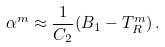<formula> <loc_0><loc_0><loc_500><loc_500>\alpha ^ { m } \approx \frac { 1 } { C _ { 2 } } ( B _ { 1 } - T _ { R } ^ { m } ) \, .</formula> 